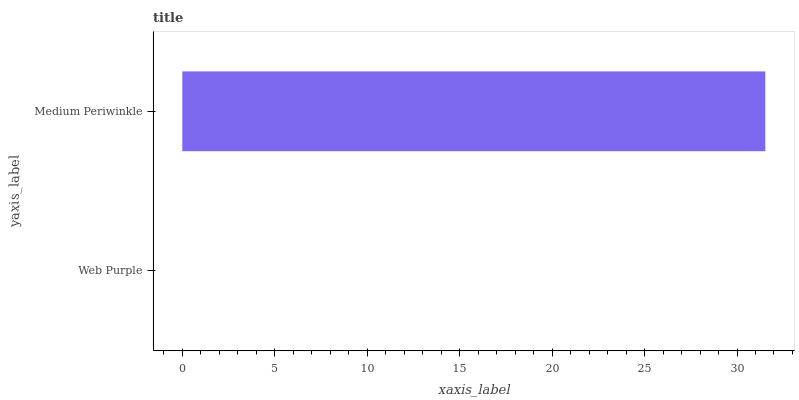Is Web Purple the minimum?
Answer yes or no. Yes. Is Medium Periwinkle the maximum?
Answer yes or no. Yes. Is Medium Periwinkle the minimum?
Answer yes or no. No. Is Medium Periwinkle greater than Web Purple?
Answer yes or no. Yes. Is Web Purple less than Medium Periwinkle?
Answer yes or no. Yes. Is Web Purple greater than Medium Periwinkle?
Answer yes or no. No. Is Medium Periwinkle less than Web Purple?
Answer yes or no. No. Is Medium Periwinkle the high median?
Answer yes or no. Yes. Is Web Purple the low median?
Answer yes or no. Yes. Is Web Purple the high median?
Answer yes or no. No. Is Medium Periwinkle the low median?
Answer yes or no. No. 